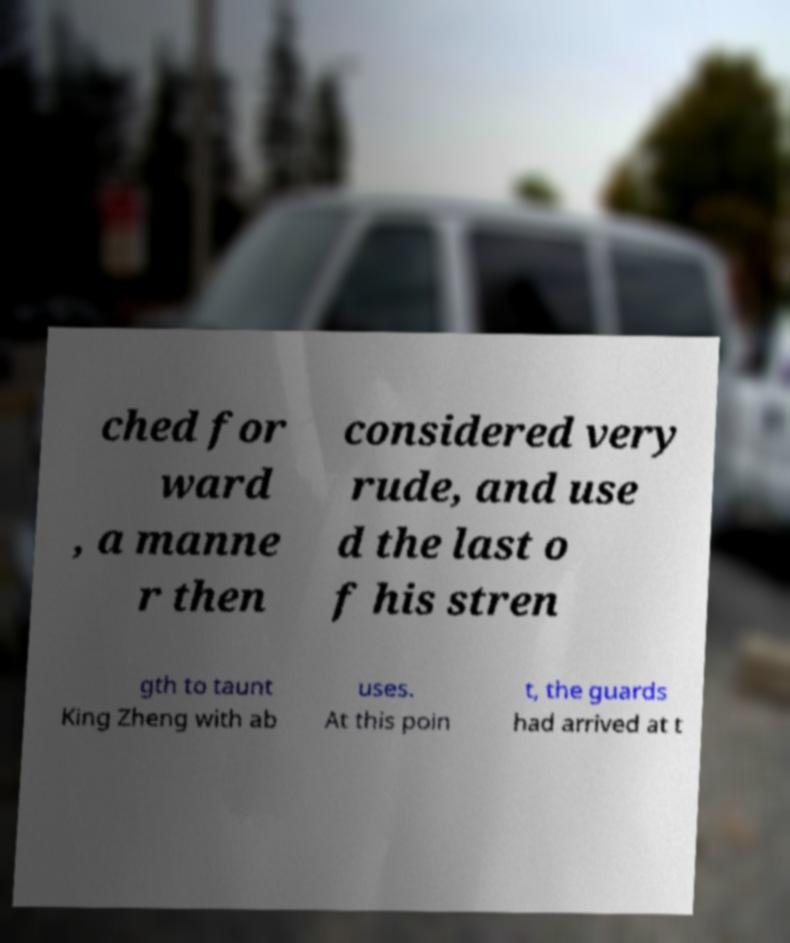Can you accurately transcribe the text from the provided image for me? ched for ward , a manne r then considered very rude, and use d the last o f his stren gth to taunt King Zheng with ab uses. At this poin t, the guards had arrived at t 